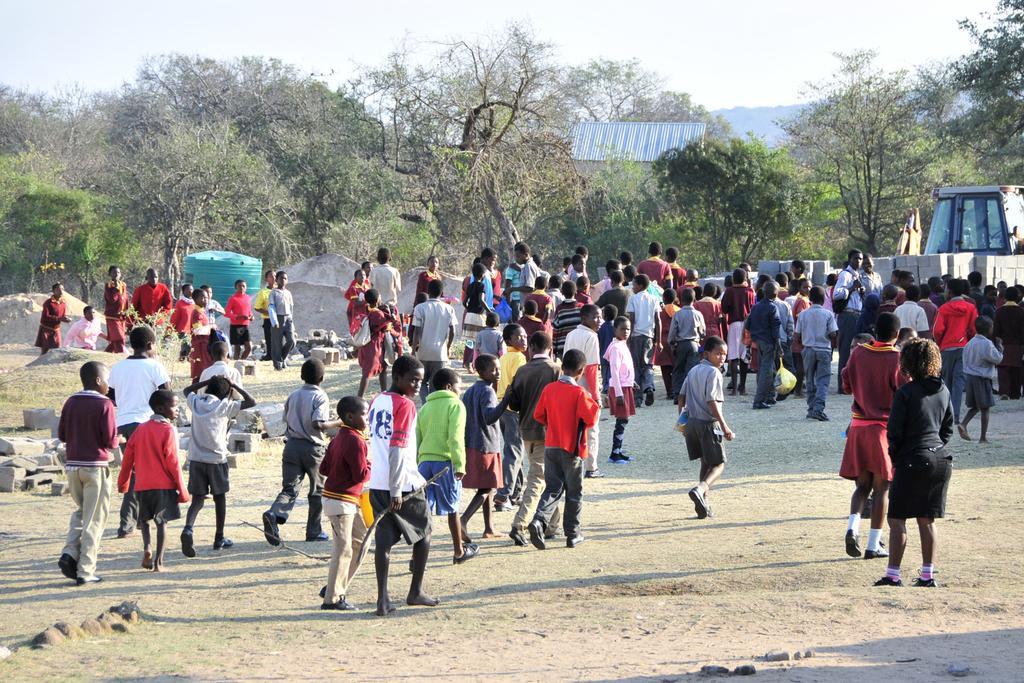In one or two sentences, can you explain what this image depicts? In this picture we can see so many people are in the ground, around we can see shade, trees. 